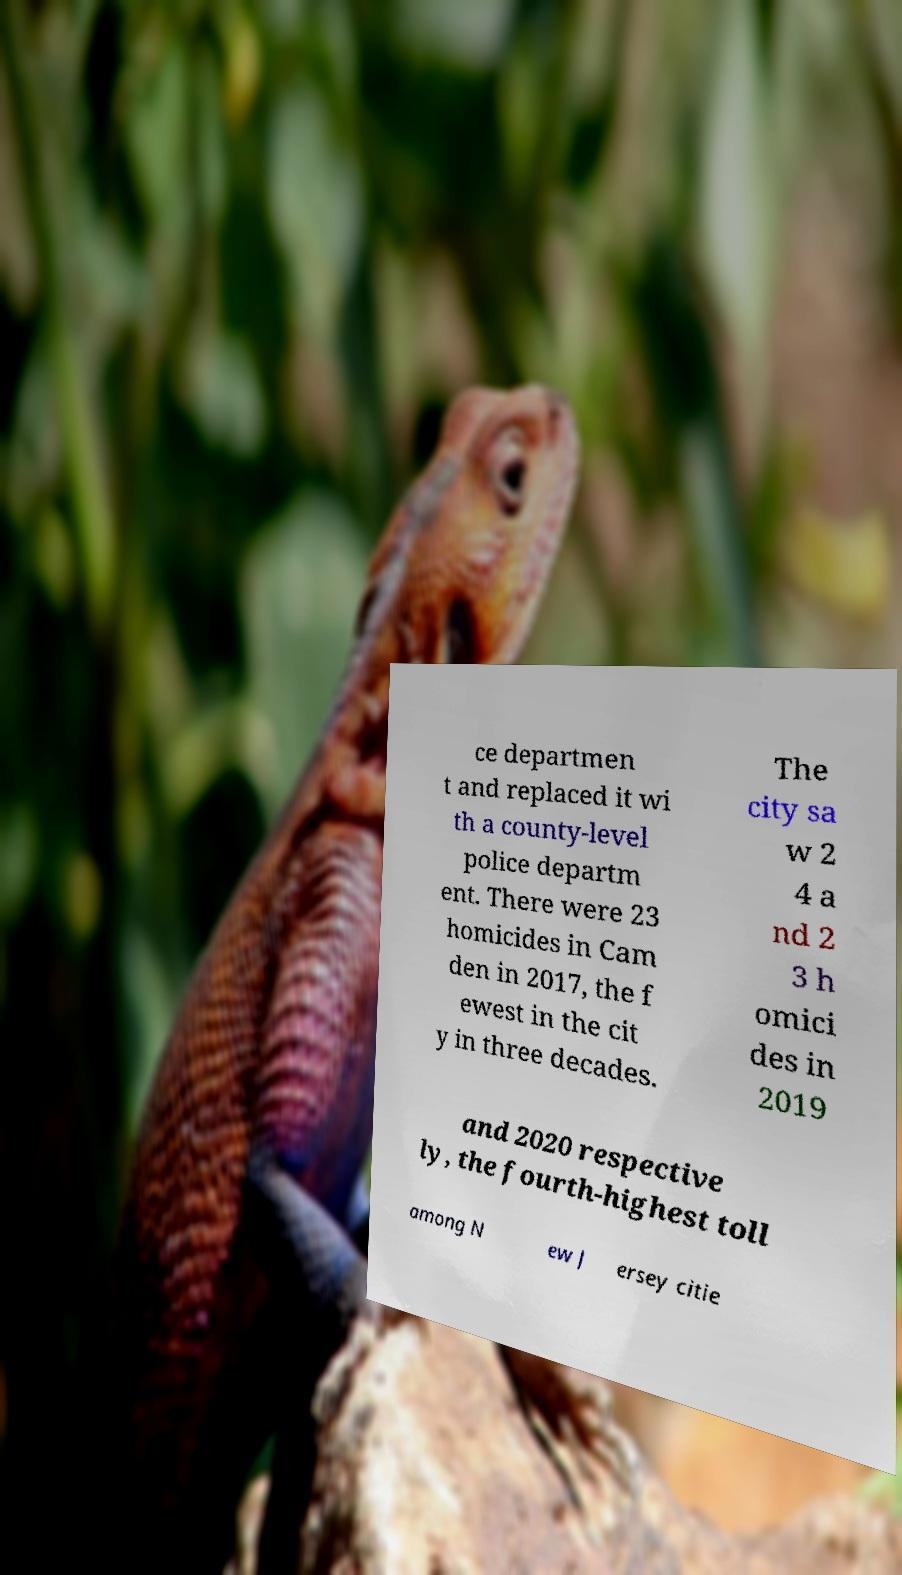For documentation purposes, I need the text within this image transcribed. Could you provide that? ce departmen t and replaced it wi th a county-level police departm ent. There were 23 homicides in Cam den in 2017, the f ewest in the cit y in three decades. The city sa w 2 4 a nd 2 3 h omici des in 2019 and 2020 respective ly, the fourth-highest toll among N ew J ersey citie 